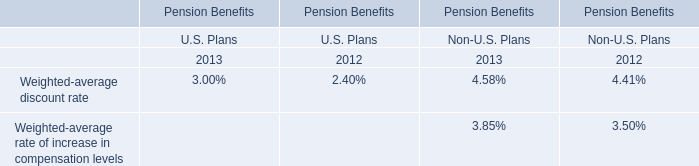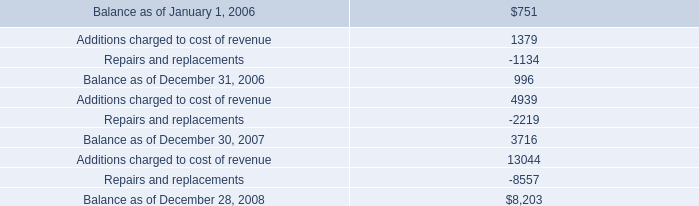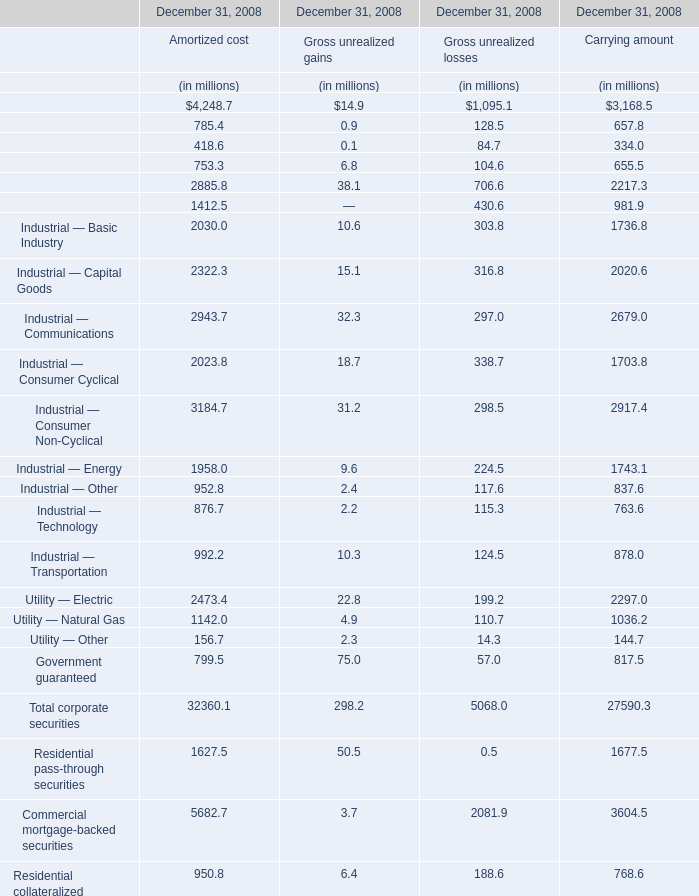what was the percentage change in the reserve for product warranties from december 30 2007 to december 28 2008? 
Computations: ((8203 - 3716) / 3716)
Answer: 1.20748. 